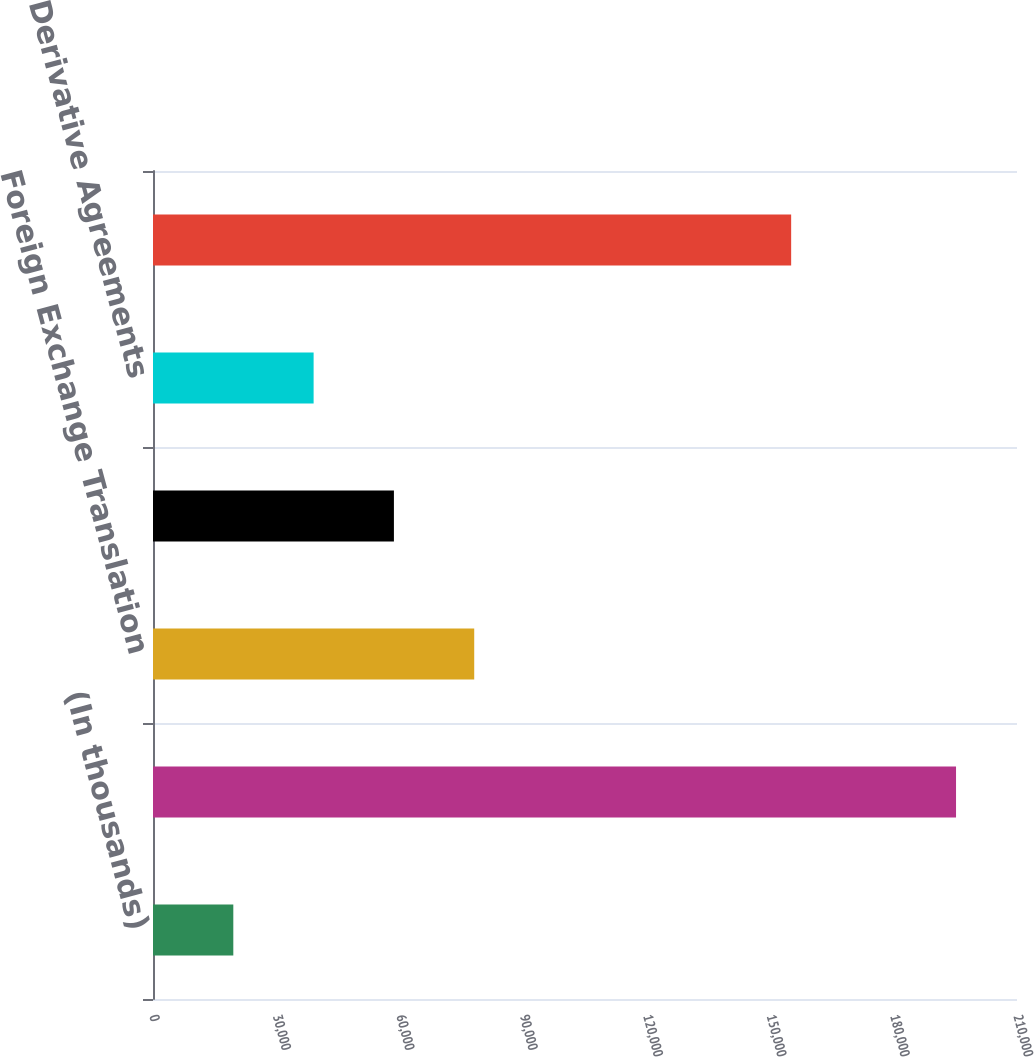<chart> <loc_0><loc_0><loc_500><loc_500><bar_chart><fcel>(In thousands)<fcel>Net Income<fcel>Foreign Exchange Translation<fcel>Defined Benefit Plan<fcel>Derivative Agreements<fcel>Comprehensive Income<nl><fcel>19520<fcel>195182<fcel>78074<fcel>58556<fcel>39038<fcel>155108<nl></chart> 